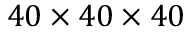<formula> <loc_0><loc_0><loc_500><loc_500>4 0 \times 4 0 \times 4 0</formula> 